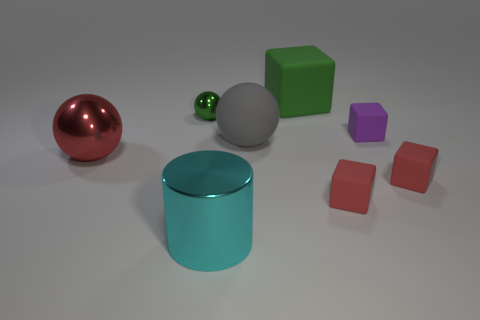What material is the big gray object in front of the green object that is to the right of the metallic object to the right of the small green metallic ball?
Ensure brevity in your answer.  Rubber. Does the small shiny object have the same color as the small block that is behind the large red sphere?
Ensure brevity in your answer.  No. How many things are green blocks that are to the left of the small purple rubber object or small things that are on the right side of the cyan metallic object?
Keep it short and to the point. 4. What shape is the large thing in front of the red thing on the left side of the cyan shiny cylinder?
Offer a terse response. Cylinder. Is there a small yellow cube that has the same material as the small green object?
Your answer should be compact. No. The tiny object that is the same shape as the large red metal thing is what color?
Provide a succinct answer. Green. Are there fewer green blocks that are left of the big cyan thing than small objects that are to the left of the green matte cube?
Offer a terse response. Yes. What number of other objects are the same shape as the big gray matte thing?
Provide a short and direct response. 2. Are there fewer cyan metal cylinders that are to the left of the cylinder than large cylinders?
Ensure brevity in your answer.  Yes. What material is the ball in front of the large gray matte ball?
Give a very brief answer. Metal. 